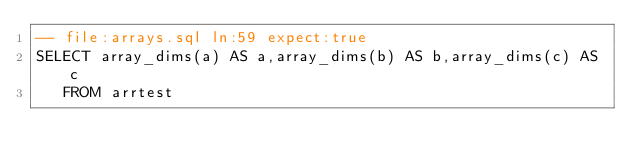Convert code to text. <code><loc_0><loc_0><loc_500><loc_500><_SQL_>-- file:arrays.sql ln:59 expect:true
SELECT array_dims(a) AS a,array_dims(b) AS b,array_dims(c) AS c
   FROM arrtest
</code> 